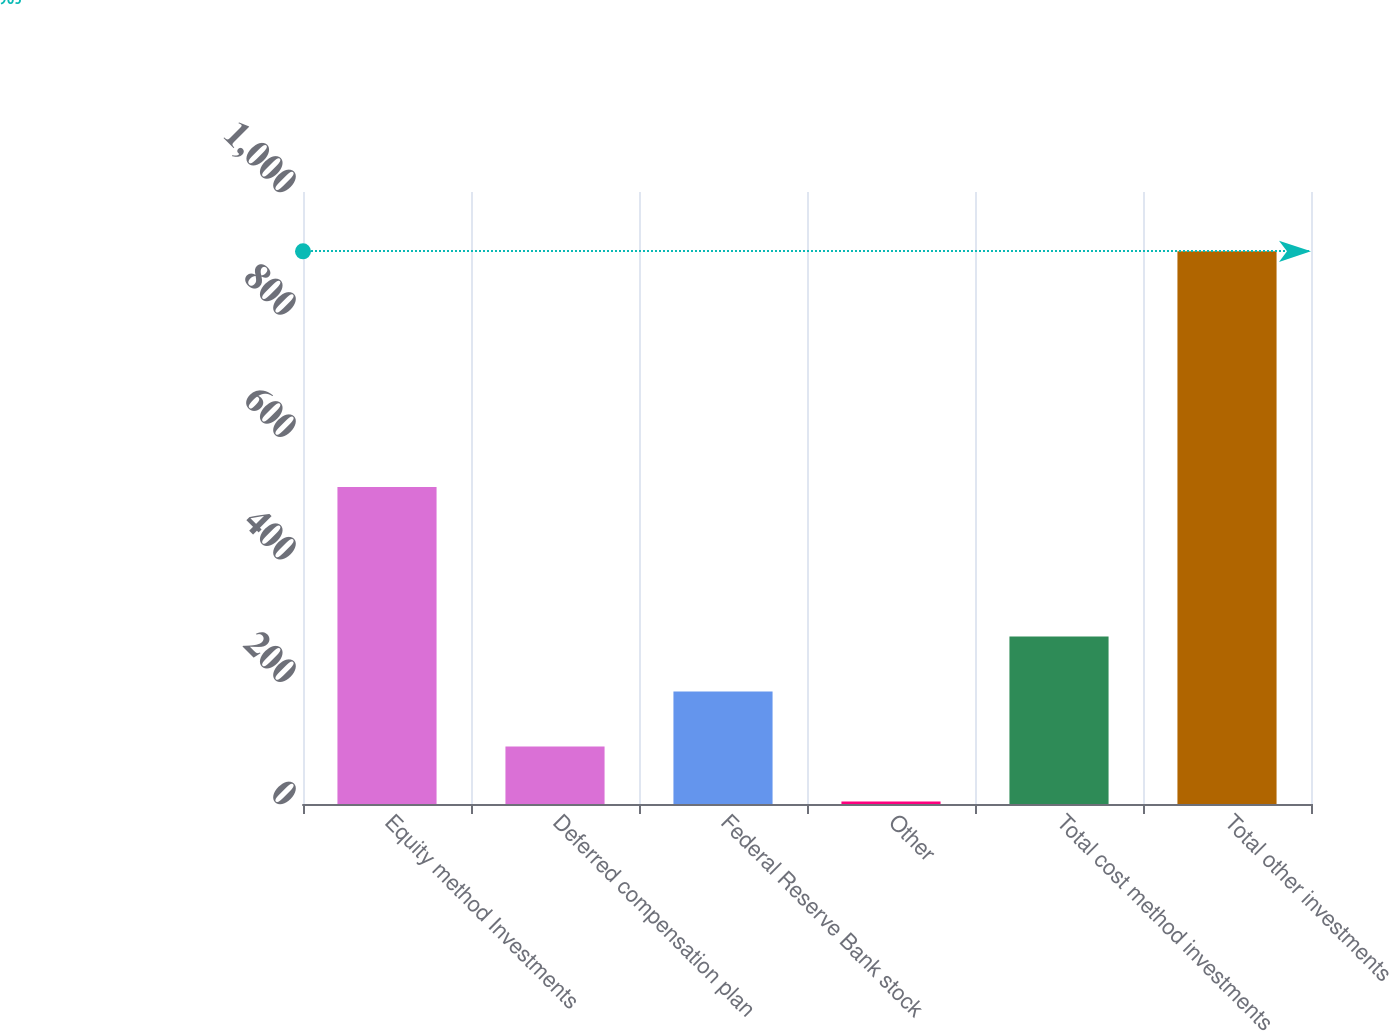Convert chart to OTSL. <chart><loc_0><loc_0><loc_500><loc_500><bar_chart><fcel>Equity method Investments<fcel>Deferred compensation plan<fcel>Federal Reserve Bank stock<fcel>Other<fcel>Total cost method investments<fcel>Total other investments<nl><fcel>518<fcel>93.9<fcel>183.8<fcel>4<fcel>273.7<fcel>903<nl></chart> 